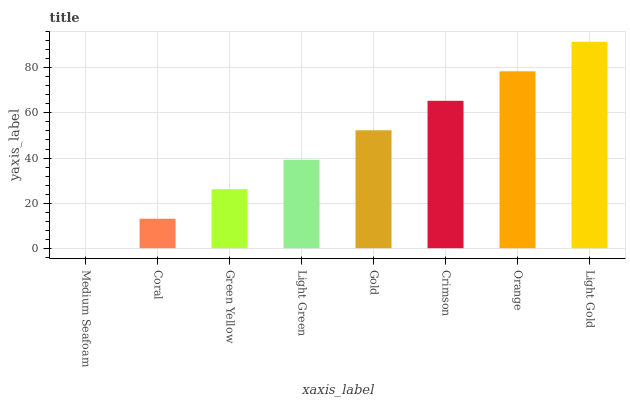Is Medium Seafoam the minimum?
Answer yes or no. Yes. Is Light Gold the maximum?
Answer yes or no. Yes. Is Coral the minimum?
Answer yes or no. No. Is Coral the maximum?
Answer yes or no. No. Is Coral greater than Medium Seafoam?
Answer yes or no. Yes. Is Medium Seafoam less than Coral?
Answer yes or no. Yes. Is Medium Seafoam greater than Coral?
Answer yes or no. No. Is Coral less than Medium Seafoam?
Answer yes or no. No. Is Gold the high median?
Answer yes or no. Yes. Is Light Green the low median?
Answer yes or no. Yes. Is Green Yellow the high median?
Answer yes or no. No. Is Medium Seafoam the low median?
Answer yes or no. No. 